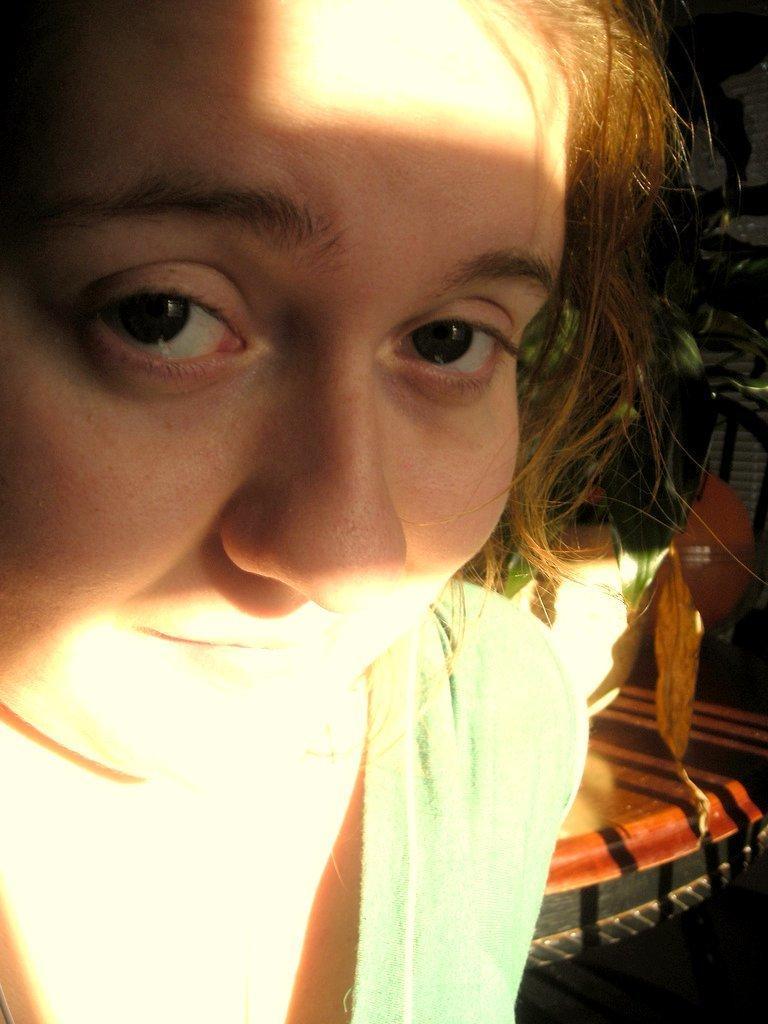Can you describe this image briefly? This image consists of a woman wearing a green dress. On the right, there are some objects. 